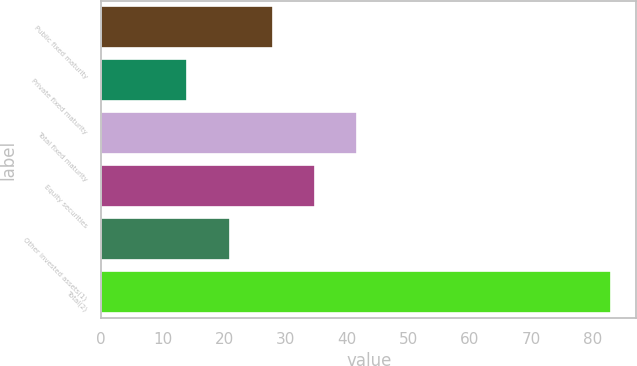<chart> <loc_0><loc_0><loc_500><loc_500><bar_chart><fcel>Public fixed maturity<fcel>Private fixed maturity<fcel>Total fixed maturity<fcel>Equity securities<fcel>Other invested assets(1)<fcel>Total(2)<nl><fcel>27.9<fcel>14<fcel>41.7<fcel>34.8<fcel>21<fcel>83<nl></chart> 